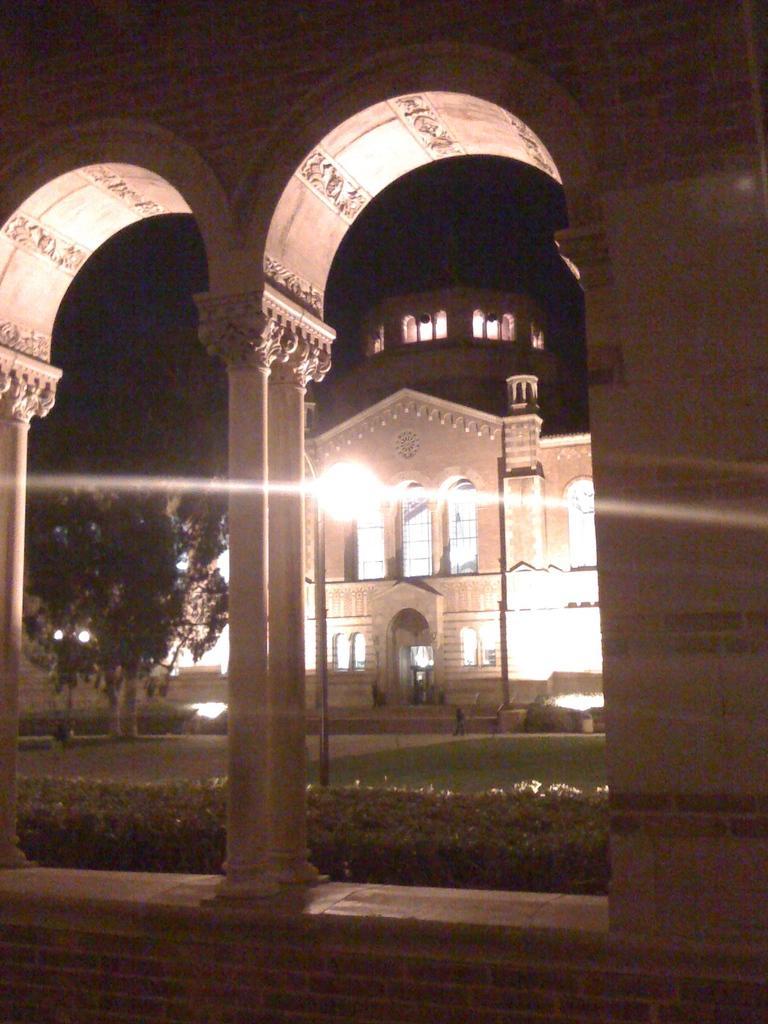Describe this image in one or two sentences. In this image I can see plants, buildings, pillars, windows, lights and trees. This image is taken may be during night. 